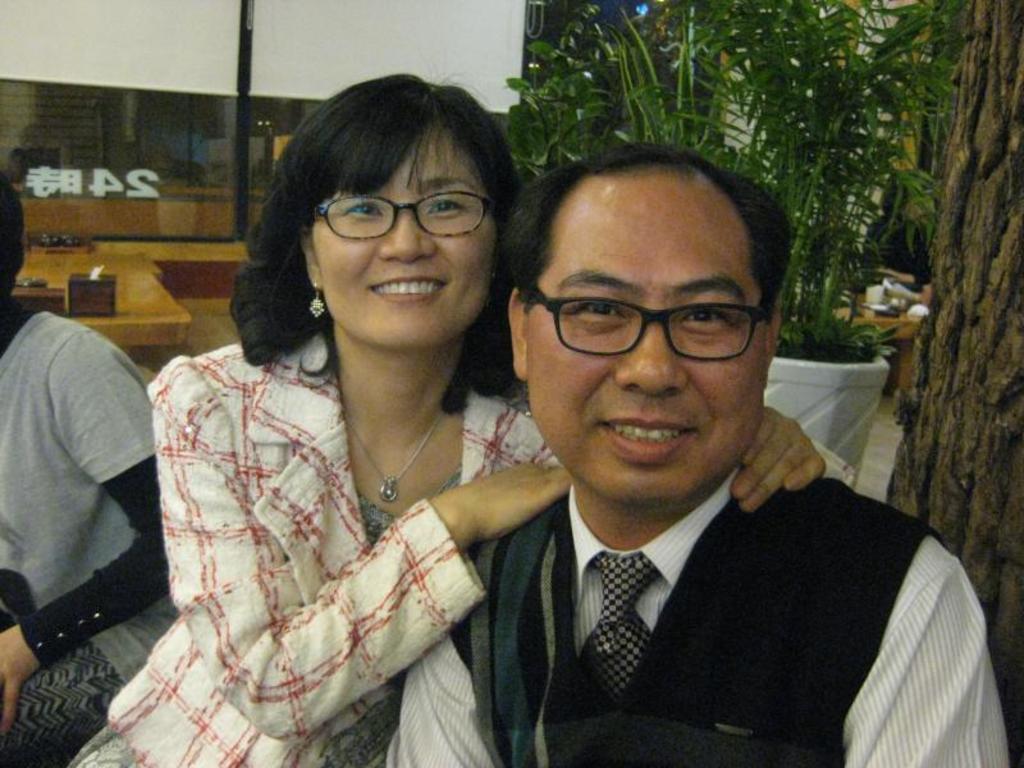Describe this image in one or two sentences. In this picture there are two persons sitting and smiling. On the left side of the image there is a person sitting. At the back there are objects on the table and there is a glass and there is a plant and tree and there is a person sitting behind the plant and there are objects on the table. At the bottom there is a floor. 